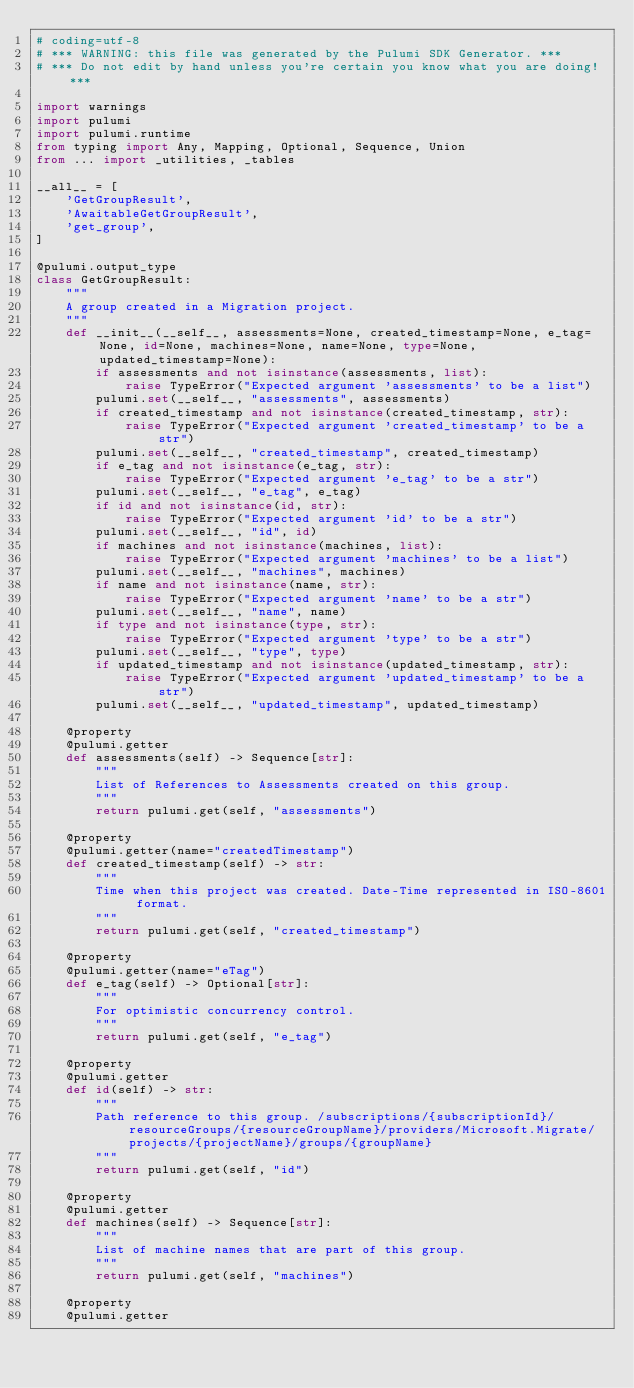Convert code to text. <code><loc_0><loc_0><loc_500><loc_500><_Python_># coding=utf-8
# *** WARNING: this file was generated by the Pulumi SDK Generator. ***
# *** Do not edit by hand unless you're certain you know what you are doing! ***

import warnings
import pulumi
import pulumi.runtime
from typing import Any, Mapping, Optional, Sequence, Union
from ... import _utilities, _tables

__all__ = [
    'GetGroupResult',
    'AwaitableGetGroupResult',
    'get_group',
]

@pulumi.output_type
class GetGroupResult:
    """
    A group created in a Migration project.
    """
    def __init__(__self__, assessments=None, created_timestamp=None, e_tag=None, id=None, machines=None, name=None, type=None, updated_timestamp=None):
        if assessments and not isinstance(assessments, list):
            raise TypeError("Expected argument 'assessments' to be a list")
        pulumi.set(__self__, "assessments", assessments)
        if created_timestamp and not isinstance(created_timestamp, str):
            raise TypeError("Expected argument 'created_timestamp' to be a str")
        pulumi.set(__self__, "created_timestamp", created_timestamp)
        if e_tag and not isinstance(e_tag, str):
            raise TypeError("Expected argument 'e_tag' to be a str")
        pulumi.set(__self__, "e_tag", e_tag)
        if id and not isinstance(id, str):
            raise TypeError("Expected argument 'id' to be a str")
        pulumi.set(__self__, "id", id)
        if machines and not isinstance(machines, list):
            raise TypeError("Expected argument 'machines' to be a list")
        pulumi.set(__self__, "machines", machines)
        if name and not isinstance(name, str):
            raise TypeError("Expected argument 'name' to be a str")
        pulumi.set(__self__, "name", name)
        if type and not isinstance(type, str):
            raise TypeError("Expected argument 'type' to be a str")
        pulumi.set(__self__, "type", type)
        if updated_timestamp and not isinstance(updated_timestamp, str):
            raise TypeError("Expected argument 'updated_timestamp' to be a str")
        pulumi.set(__self__, "updated_timestamp", updated_timestamp)

    @property
    @pulumi.getter
    def assessments(self) -> Sequence[str]:
        """
        List of References to Assessments created on this group.
        """
        return pulumi.get(self, "assessments")

    @property
    @pulumi.getter(name="createdTimestamp")
    def created_timestamp(self) -> str:
        """
        Time when this project was created. Date-Time represented in ISO-8601 format.
        """
        return pulumi.get(self, "created_timestamp")

    @property
    @pulumi.getter(name="eTag")
    def e_tag(self) -> Optional[str]:
        """
        For optimistic concurrency control.
        """
        return pulumi.get(self, "e_tag")

    @property
    @pulumi.getter
    def id(self) -> str:
        """
        Path reference to this group. /subscriptions/{subscriptionId}/resourceGroups/{resourceGroupName}/providers/Microsoft.Migrate/projects/{projectName}/groups/{groupName}
        """
        return pulumi.get(self, "id")

    @property
    @pulumi.getter
    def machines(self) -> Sequence[str]:
        """
        List of machine names that are part of this group.
        """
        return pulumi.get(self, "machines")

    @property
    @pulumi.getter</code> 